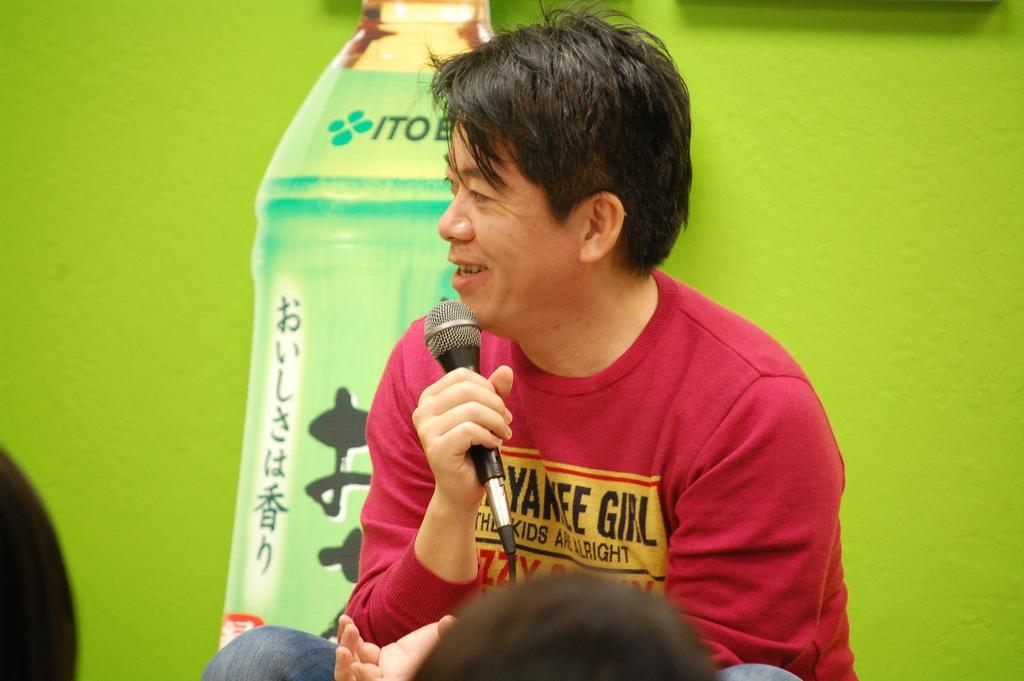Describe this image in one or two sentences. In this image, In the middle there is a man holding a microphone and talking something,In the background there is a green color wall. 